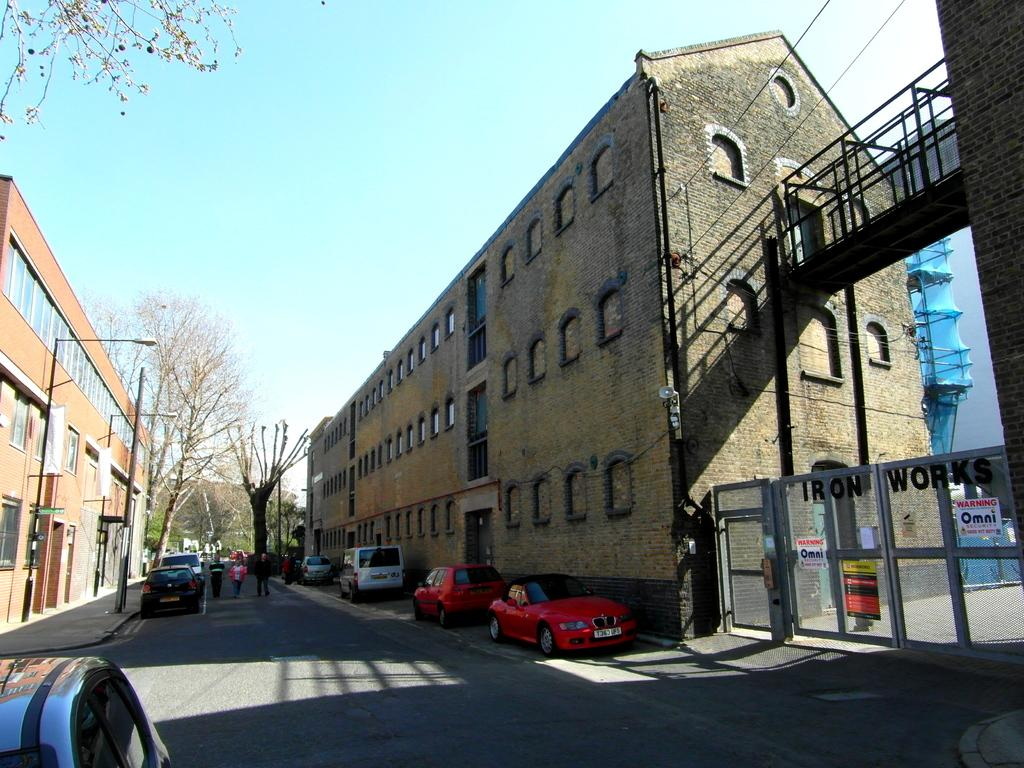What is in the foreground of the image? There is a road in the foreground of the image. What can be seen alongside the road? Vehicles are parked alongside the road. What is visible in the background of the image? There are buildings, trees, poles, a gate, and the sky in the background of the image. What type of meal is being prepared in the image? There is no meal preparation visible in the image; it primarily features a road and various background elements. 